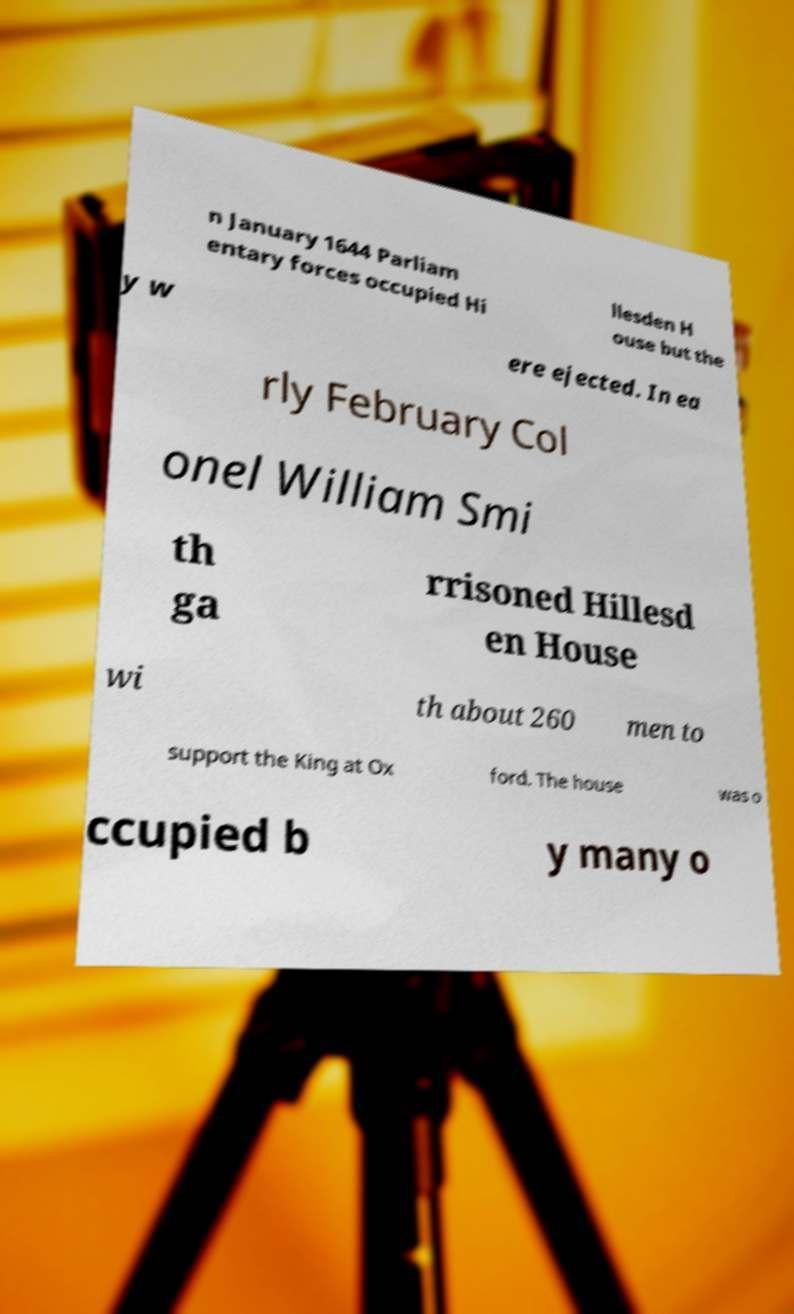Can you accurately transcribe the text from the provided image for me? n January 1644 Parliam entary forces occupied Hi llesden H ouse but the y w ere ejected. In ea rly February Col onel William Smi th ga rrisoned Hillesd en House wi th about 260 men to support the King at Ox ford. The house was o ccupied b y many o 